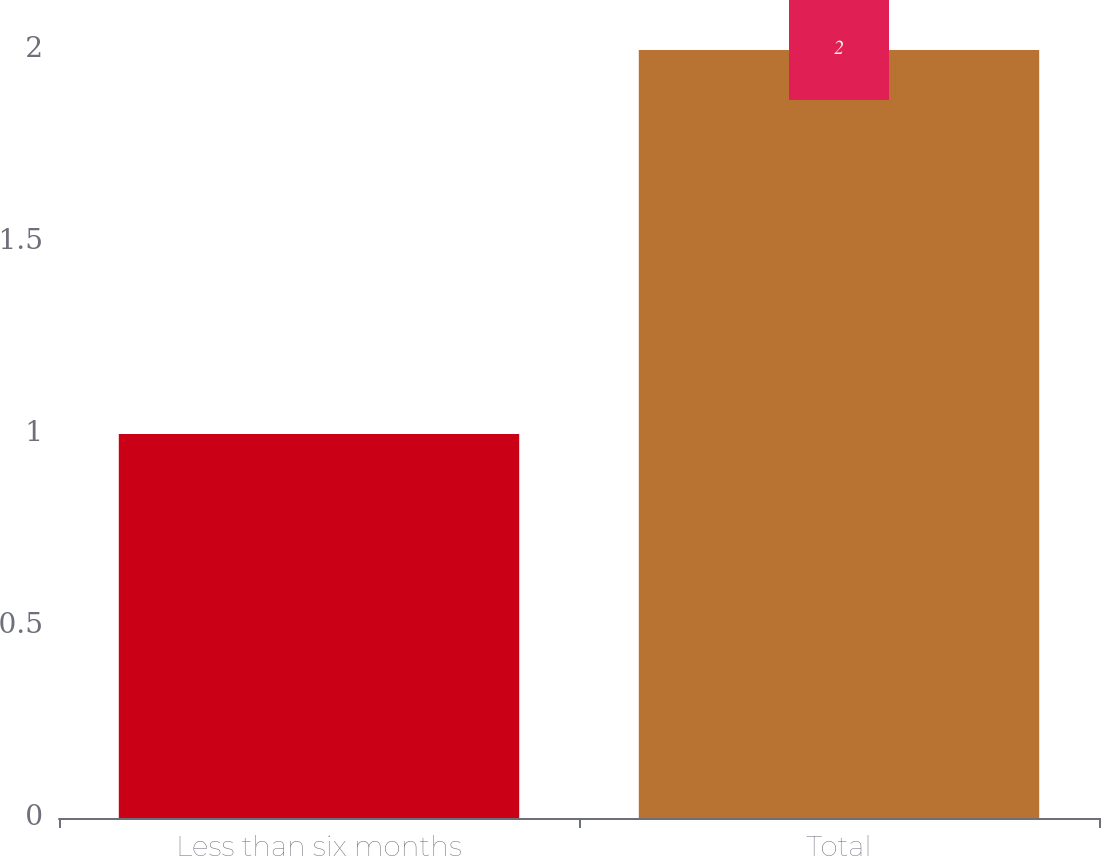<chart> <loc_0><loc_0><loc_500><loc_500><bar_chart><fcel>Less than six months<fcel>Total<nl><fcel>1<fcel>2<nl></chart> 